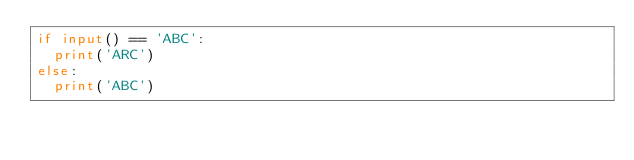<code> <loc_0><loc_0><loc_500><loc_500><_Python_>if input() == 'ABC':
  print('ARC')
else:
  print('ABC')
</code> 